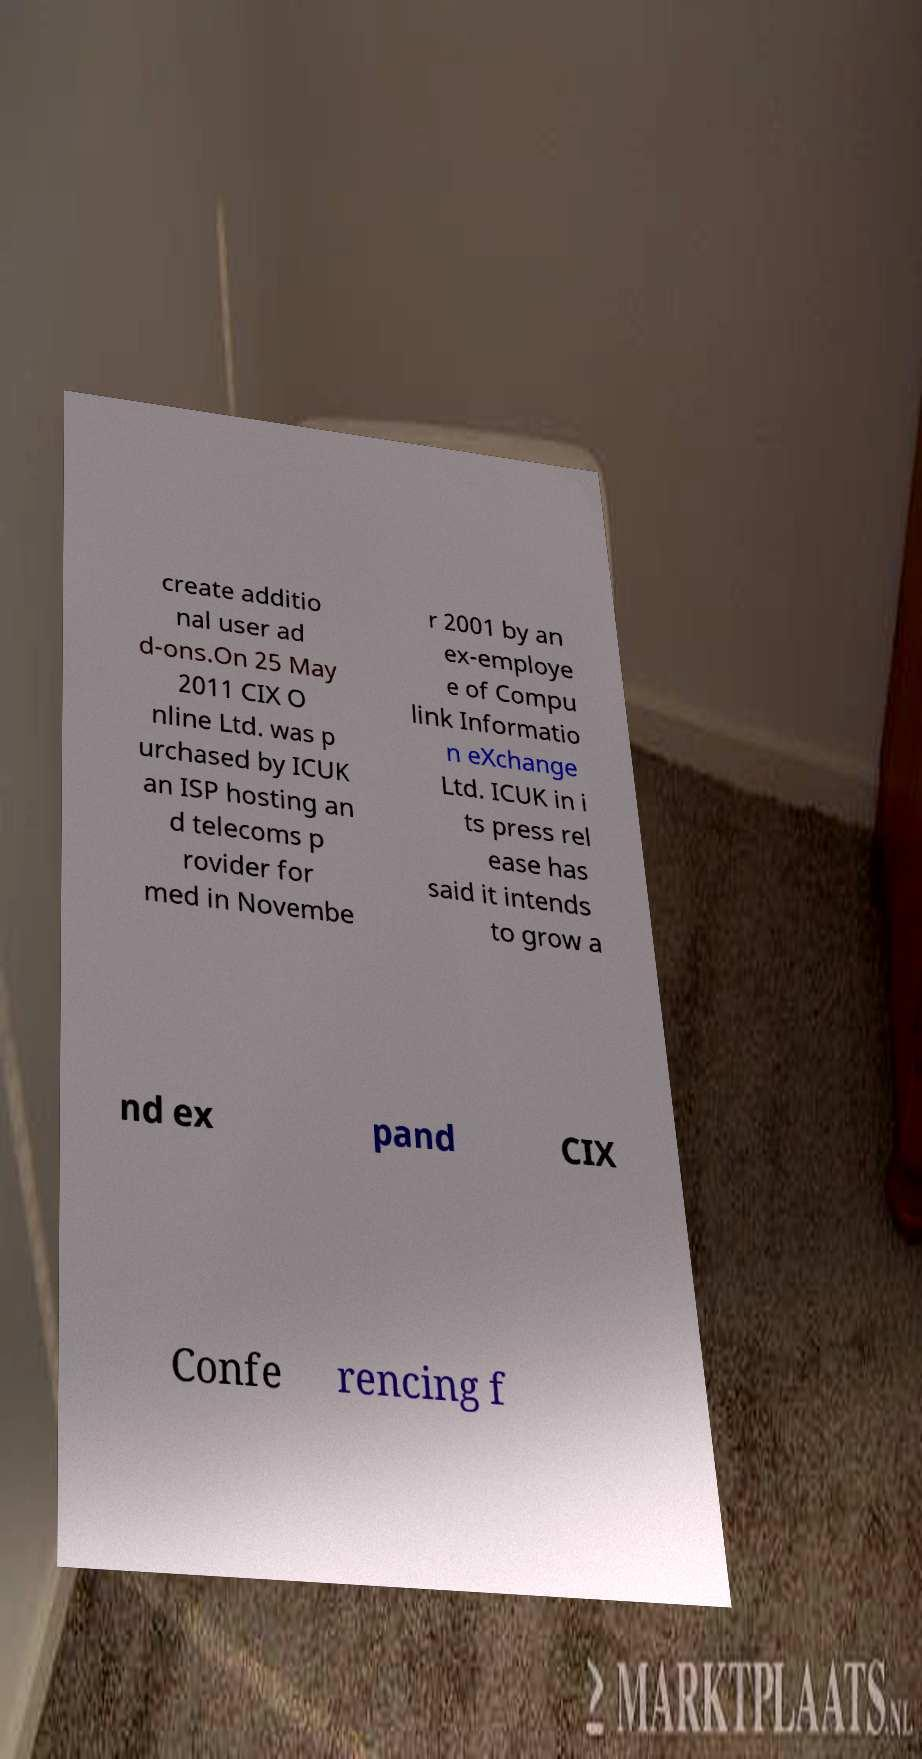Can you accurately transcribe the text from the provided image for me? create additio nal user ad d-ons.On 25 May 2011 CIX O nline Ltd. was p urchased by ICUK an ISP hosting an d telecoms p rovider for med in Novembe r 2001 by an ex-employe e of Compu link Informatio n eXchange Ltd. ICUK in i ts press rel ease has said it intends to grow a nd ex pand CIX Confe rencing f 